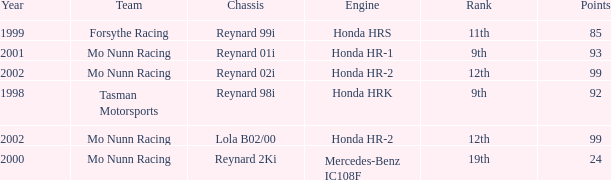What is the rank of the reynard 2ki chassis before 2002? 19th. 